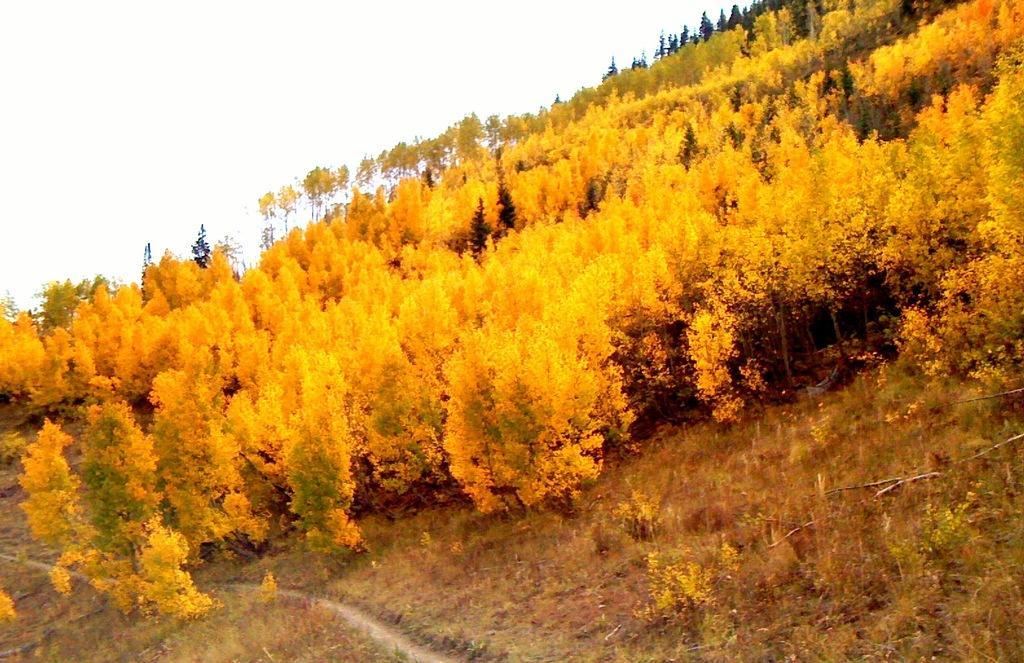Could you give a brief overview of what you see in this image? In this picture I can see yellow color trees, grass and the sky in the background. 